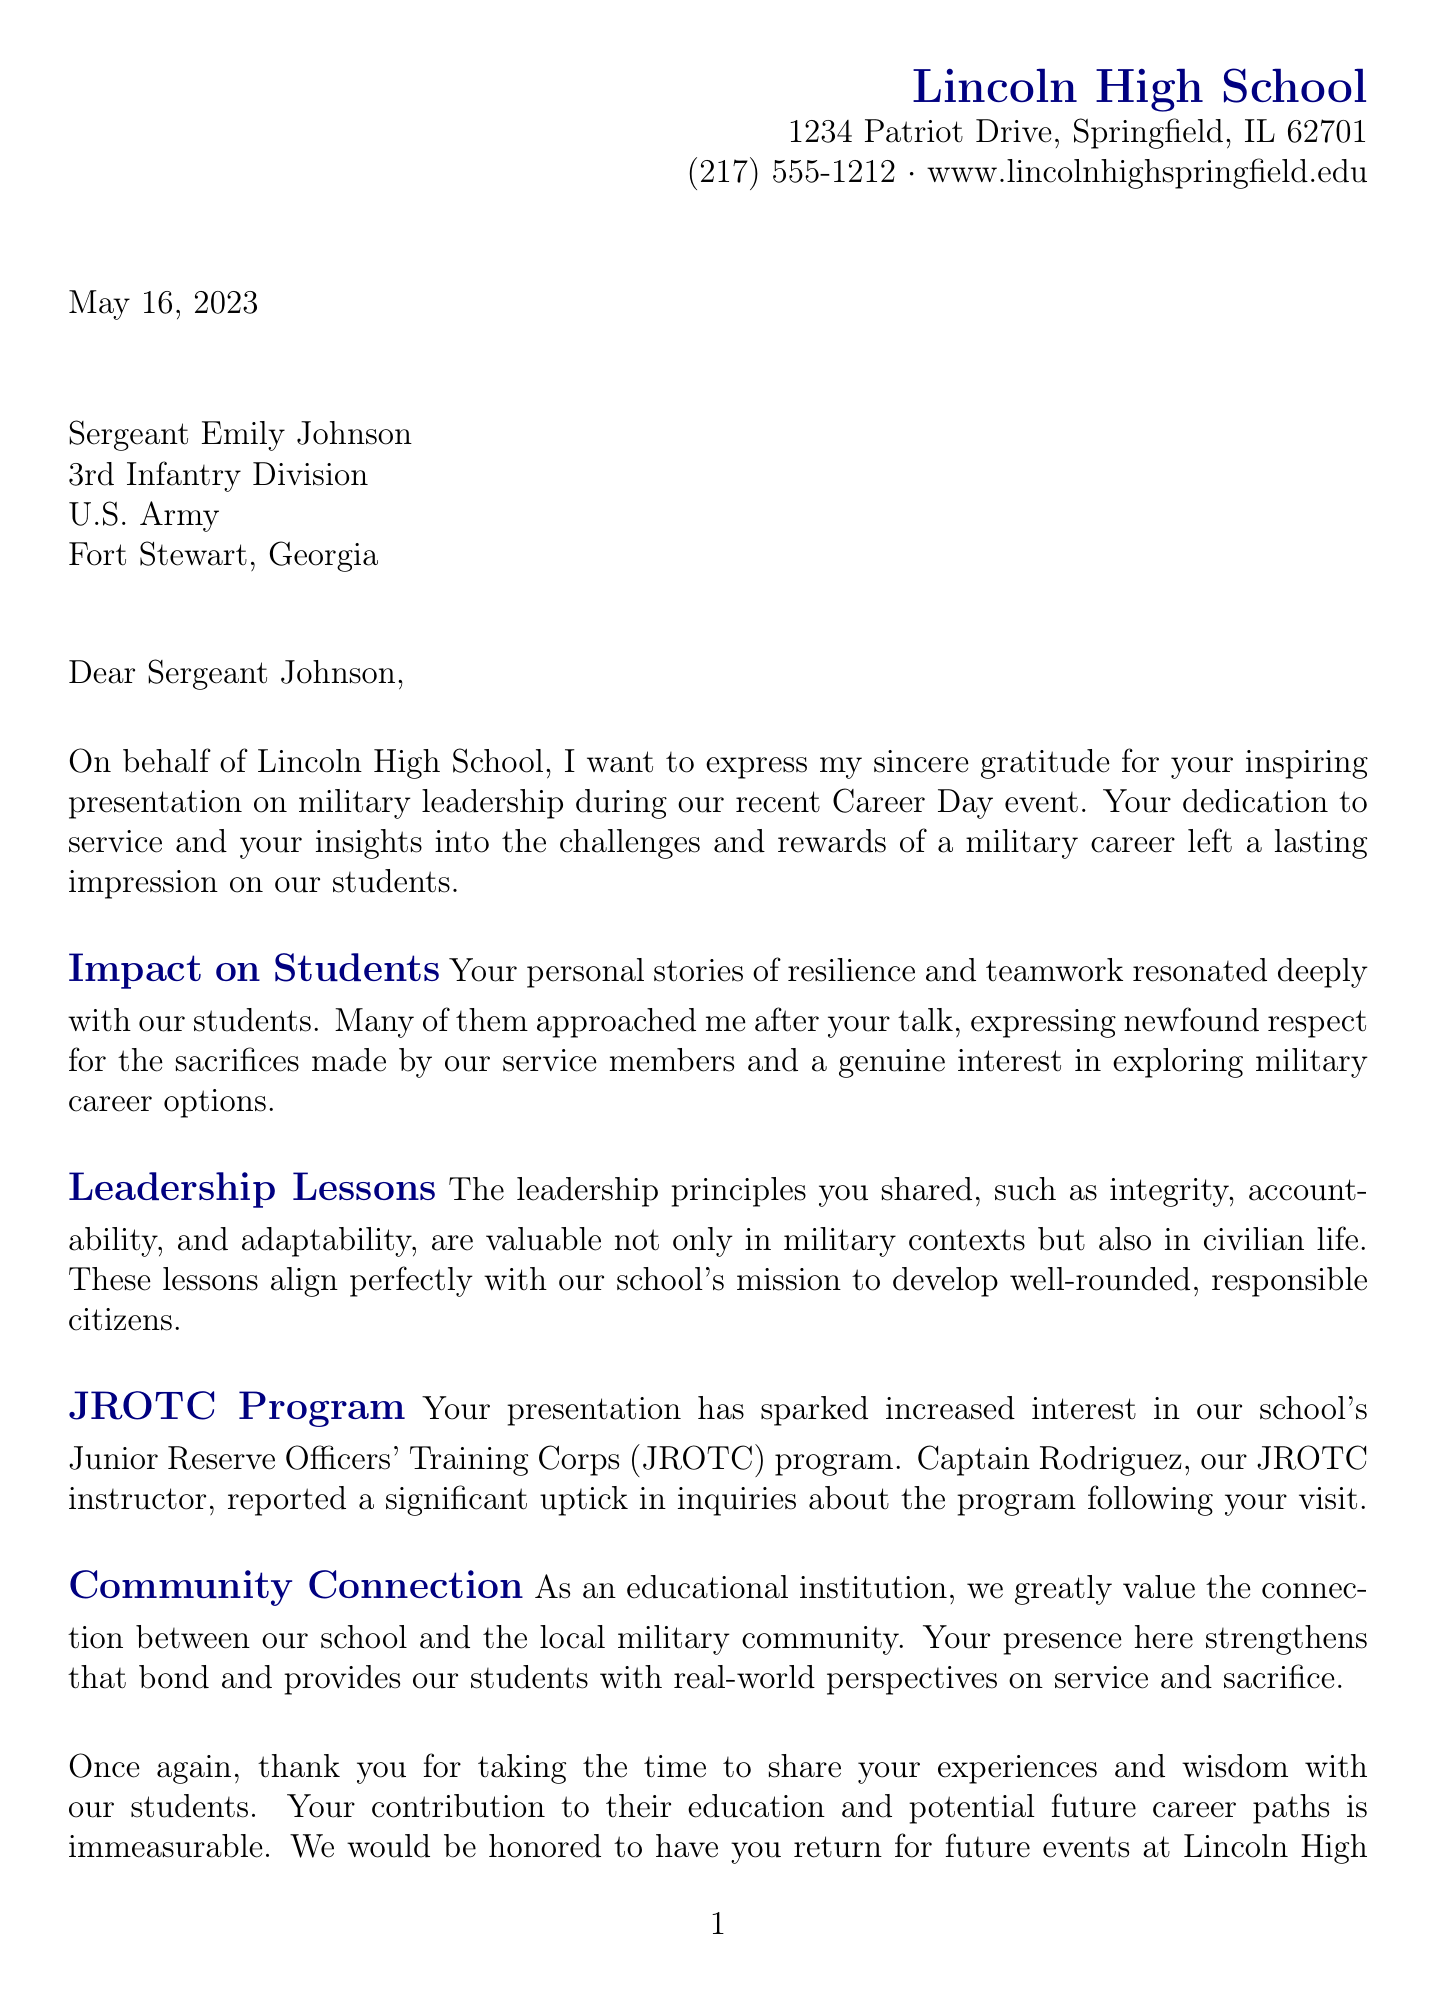What is the date of the event? The event took place on May 15, 2023, as indicated in the document.
Answer: May 15, 2023 Who is the letter addressed to? The letter is specifically addressed to Sergeant Emily Johnson, as stated in the salutation.
Answer: Sergeant Emily Johnson What school is Principal Sarah Thompson from? The document states that Principal Sarah Thompson is from Lincoln High School, confirming the school's name.
Answer: Lincoln High School How many students attended the event? The document mentions that 350 students attended from grades 9-12.
Answer: 350 students What military unit does Sergeant Johnson belong to? The document specifies that Sergeant Johnson is from the 3rd Infantry Division.
Answer: 3rd Infantry Division What topic sparked increased interest in the JROTC program? Interest in the JROTC program increased due to Sergeant Johnson's presentation, as noted in the document's body paragraphs.
Answer: Presentation What is the duration of the presentation? The letter states that the presentation lasted for 45 minutes, followed by a 15-minute Q&A session, detailing the full time allocated.
Answer: 45 minutes What is the main purpose of the letter? The primary purpose of the letter is to express gratitude for Sergeant Johnson's presentation and its impact on students.
Answer: Gratitude Which leadership principles were highlighted in the talk? The principles mentioned in the letter include integrity, accountability, and adaptability, which were shared by Sergeant Johnson.
Answer: Integrity, accountability, adaptability 